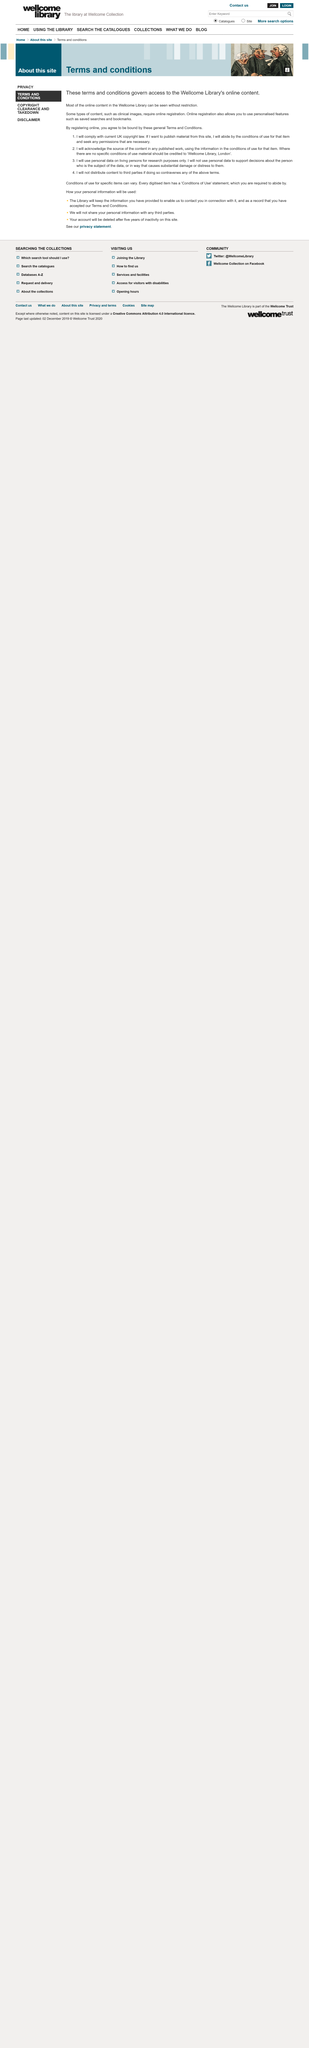Draw attention to some important aspects in this diagram. In the image, three individuals can be observed. It is common for clinical images to require online registration in order to ensure their accurate and secure storage and retrieval. The terms and conditions govern access to the Wellcome Library's online content. 